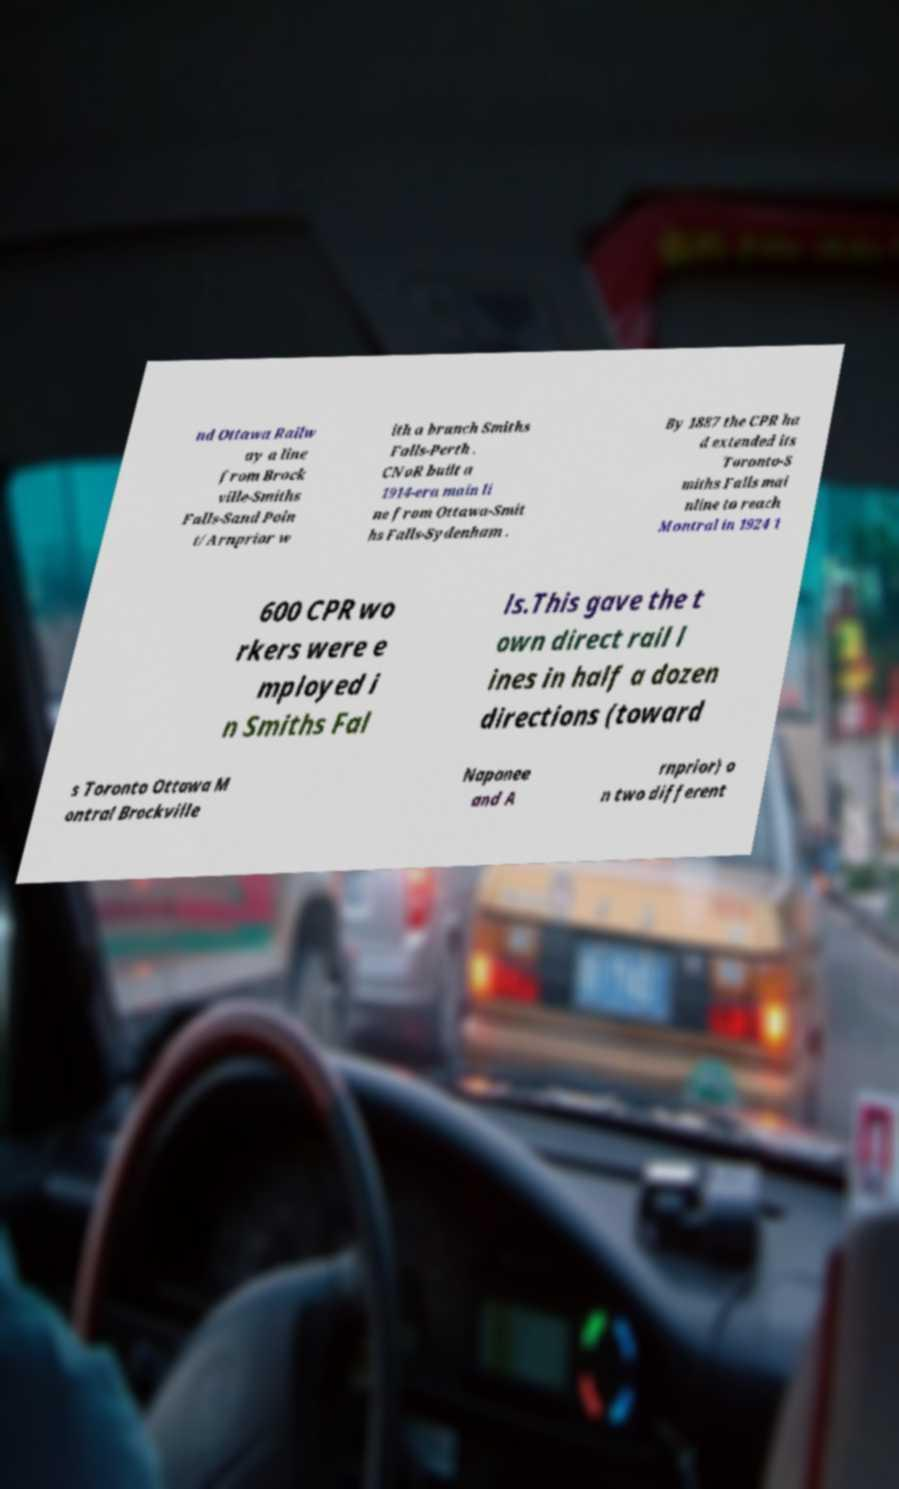What messages or text are displayed in this image? I need them in a readable, typed format. nd Ottawa Railw ay a line from Brock ville-Smiths Falls-Sand Poin t/Arnprior w ith a branch Smiths Falls-Perth . CNoR built a 1914-era main li ne from Ottawa-Smit hs Falls-Sydenham . By 1887 the CPR ha d extended its Toronto-S miths Falls mai nline to reach Montral in 1924 1 600 CPR wo rkers were e mployed i n Smiths Fal ls.This gave the t own direct rail l ines in half a dozen directions (toward s Toronto Ottawa M ontral Brockville Napanee and A rnprior) o n two different 